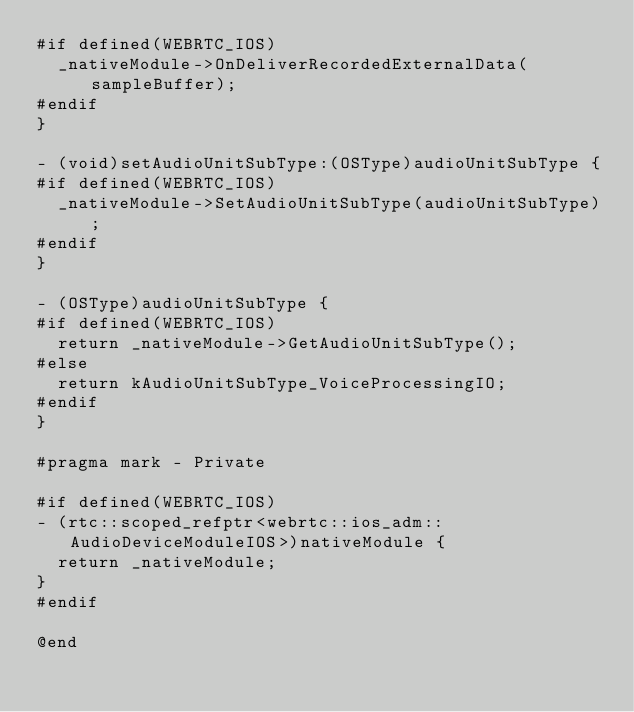<code> <loc_0><loc_0><loc_500><loc_500><_ObjectiveC_>#if defined(WEBRTC_IOS)
  _nativeModule->OnDeliverRecordedExternalData(sampleBuffer);
#endif
}

- (void)setAudioUnitSubType:(OSType)audioUnitSubType {
#if defined(WEBRTC_IOS)
  _nativeModule->SetAudioUnitSubType(audioUnitSubType);
#endif
}

- (OSType)audioUnitSubType {
#if defined(WEBRTC_IOS)
  return _nativeModule->GetAudioUnitSubType();
#else
  return kAudioUnitSubType_VoiceProcessingIO;
#endif
}

#pragma mark - Private

#if defined(WEBRTC_IOS)
- (rtc::scoped_refptr<webrtc::ios_adm::AudioDeviceModuleIOS>)nativeModule {
  return _nativeModule;
}
#endif

@end
</code> 